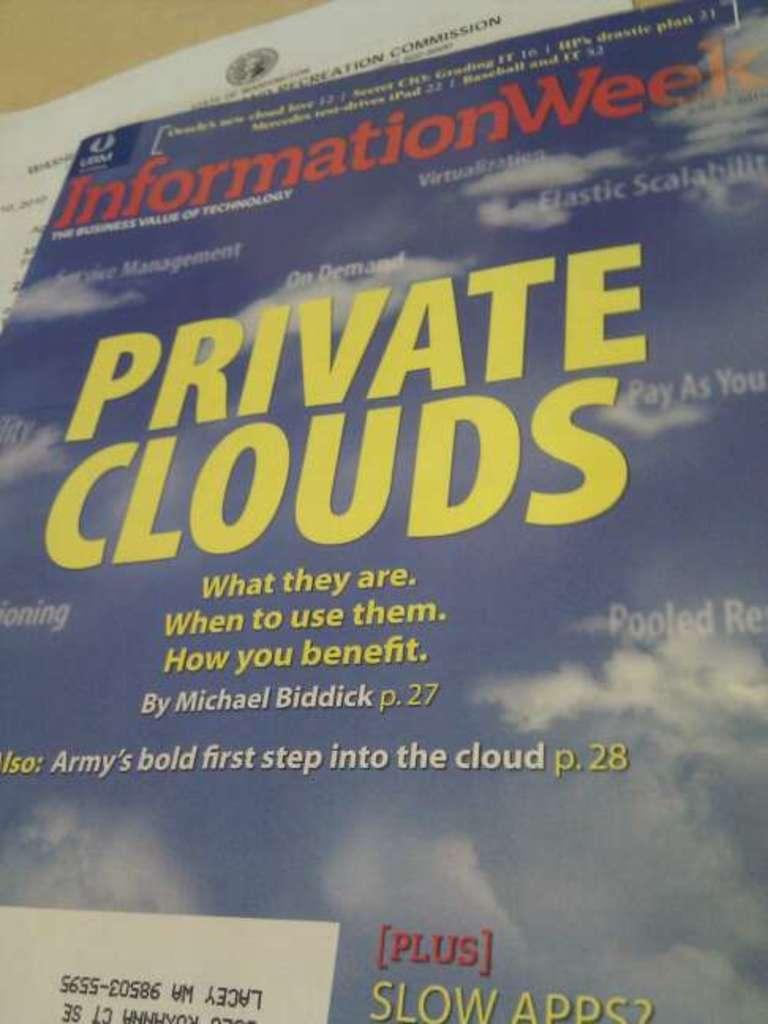<image>
Describe the image concisely. Private clouds magazine from Information week virtualization by Michael Biddick. 